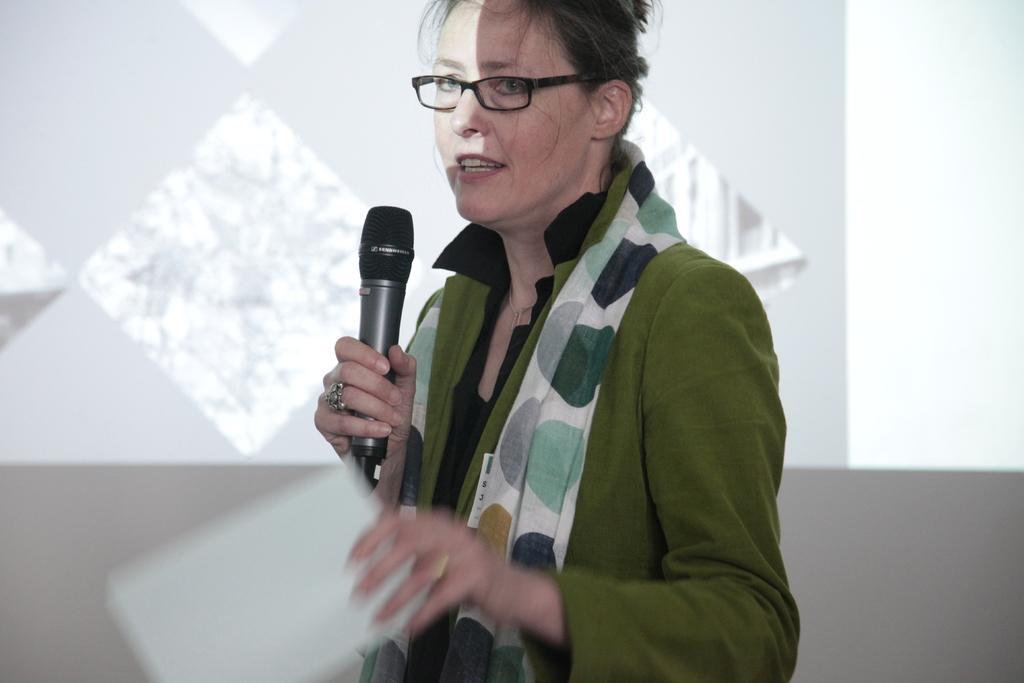How would you summarize this image in a sentence or two? In the picture I can see a woman wearing green jacket is holding a paper in one of her hand and a mic in her another hand and speaking in front of it and there is a projected image in the background. 